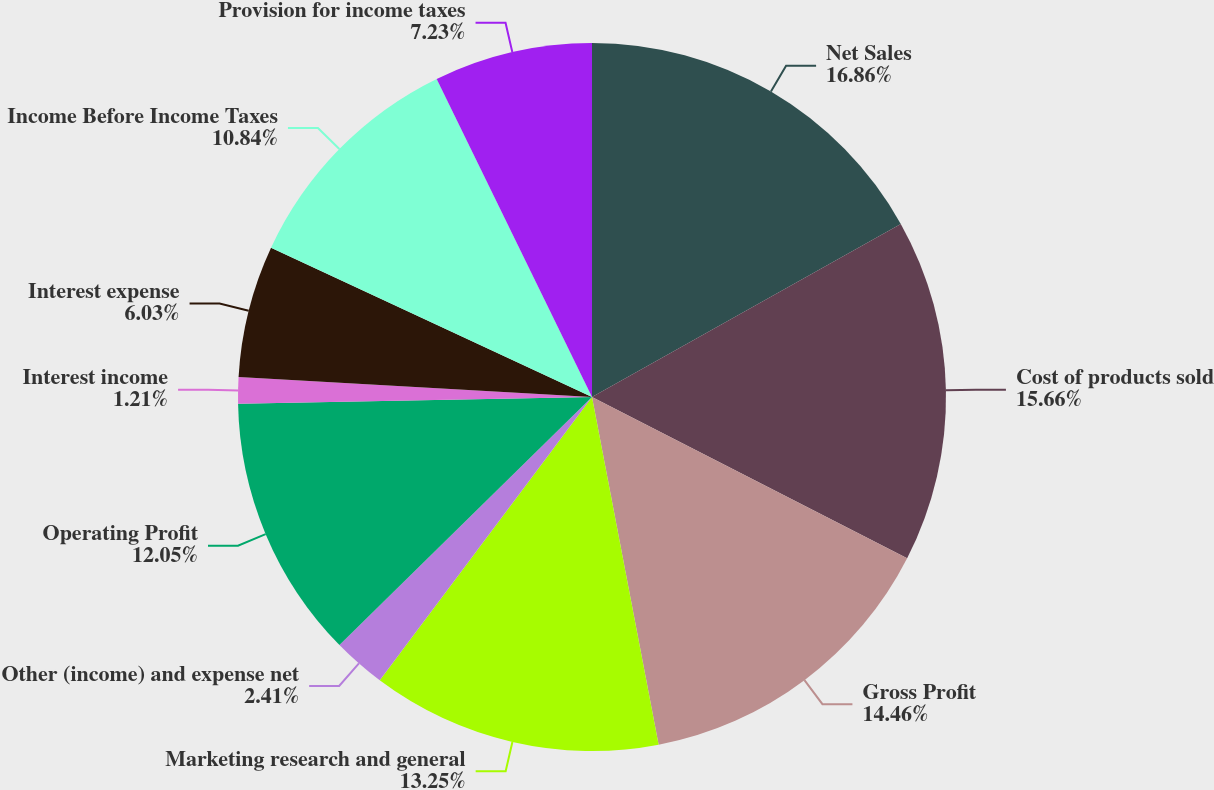<chart> <loc_0><loc_0><loc_500><loc_500><pie_chart><fcel>Net Sales<fcel>Cost of products sold<fcel>Gross Profit<fcel>Marketing research and general<fcel>Other (income) and expense net<fcel>Operating Profit<fcel>Interest income<fcel>Interest expense<fcel>Income Before Income Taxes<fcel>Provision for income taxes<nl><fcel>16.87%<fcel>15.66%<fcel>14.46%<fcel>13.25%<fcel>2.41%<fcel>12.05%<fcel>1.21%<fcel>6.03%<fcel>10.84%<fcel>7.23%<nl></chart> 